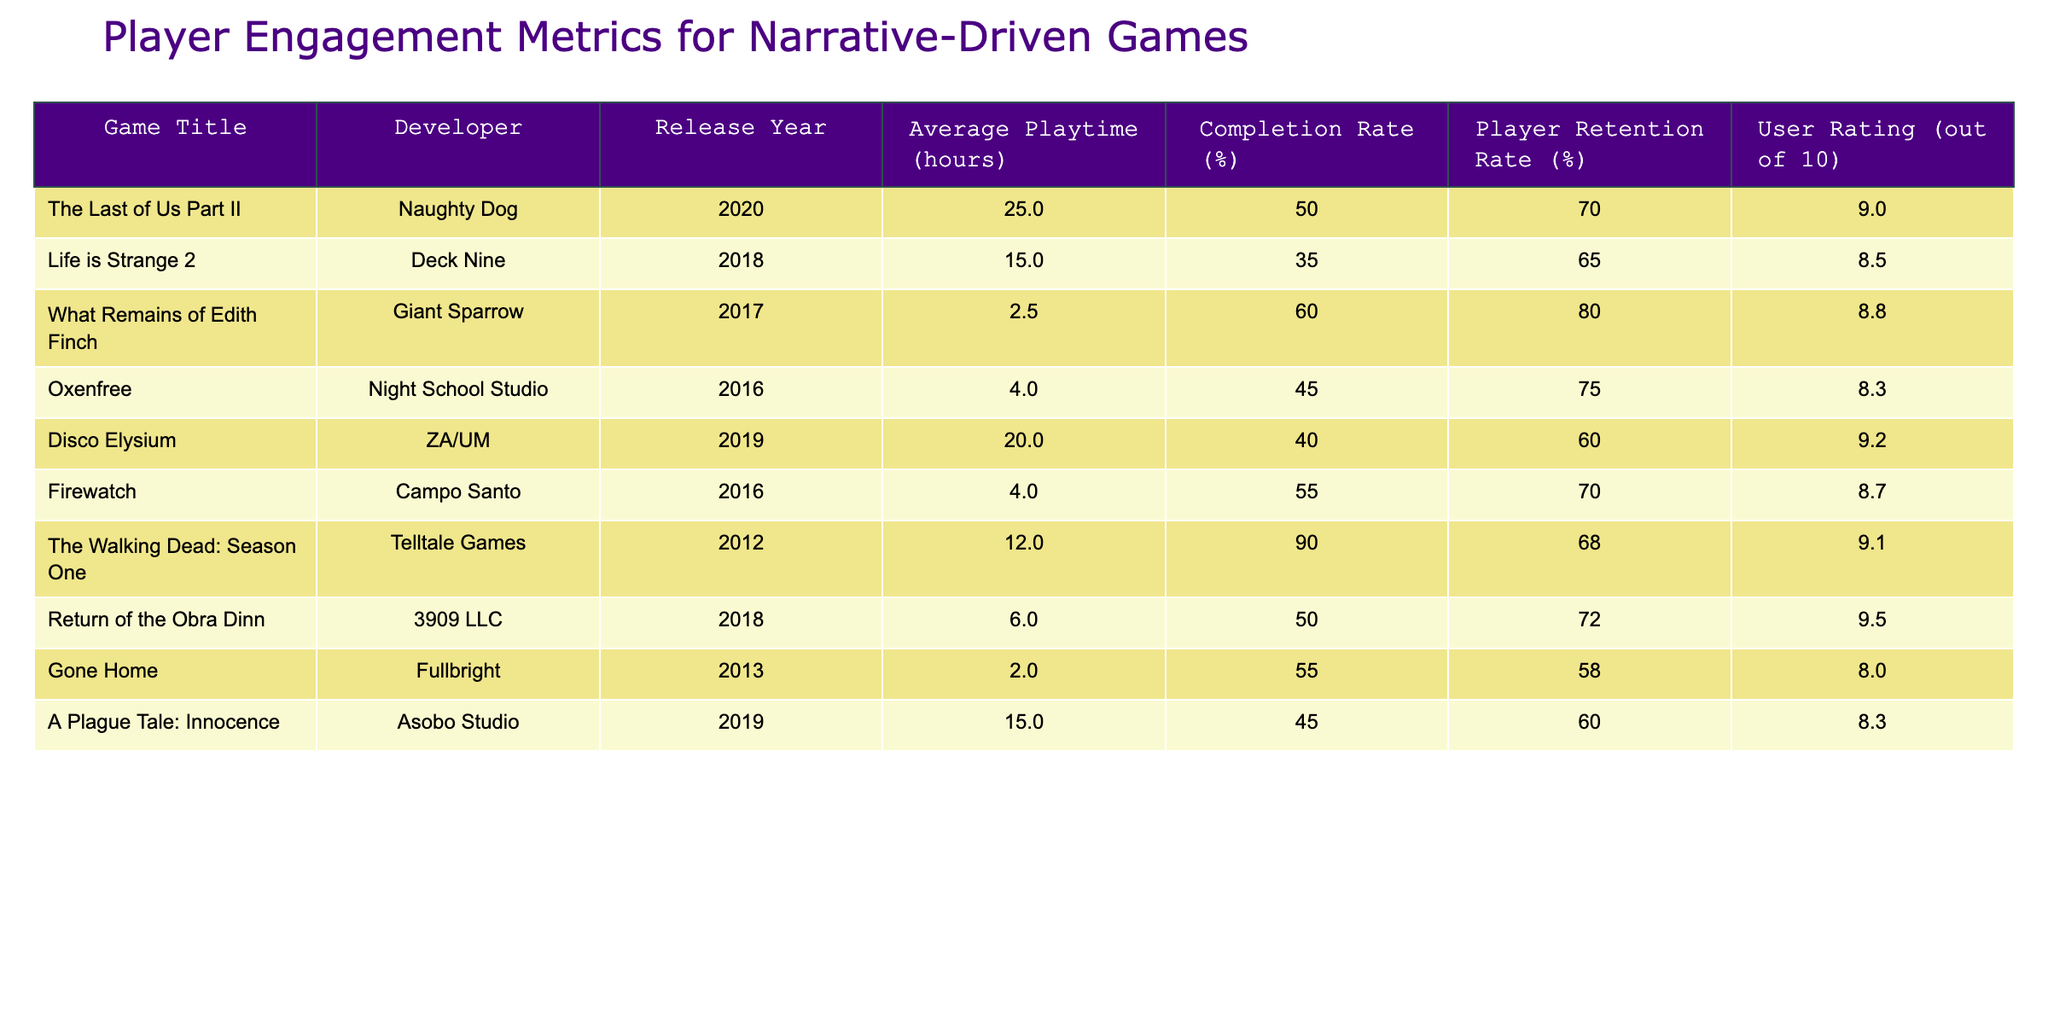What game has the highest player retention rate? By reviewing the "Player Retention Rate (%)" column in the table, we can see that "What Remains of Edith Finch" has a player retention rate of 80%, which is the highest among all the games listed.
Answer: What Remains of Edith Finch What is the average playtime of the games developed by Naughty Dog? The table shows that "The Last of Us Part II" is the only game by Naughty Dog, with an average playtime of 25 hours. Thus, the average playtime is simply 25 hours.
Answer: 25 hours What percentage of players completed "Life is Strange 2"? In the table, we find that "Life is Strange 2" has a completion rate of 35% listed under the "Completion Rate (%)" column.
Answer: 35% Is the user rating for "Return of the Obra Dinn" greater than 9? Looking at the "User Rating (out of 10)" column, "Return of the Obra Dinn" has a rating of 9.5, which is greater than 9, so the answer is yes.
Answer: Yes What is the difference in average playtime between "Oxenfree" and "Gone Home"? The average playtime for "Oxenfree" is 4 hours and for "Gone Home" it is 2 hours. The difference is calculated as 4 - 2 = 2 hours.
Answer: 2 hours Which game has the lowest user rating and what is it? By examining the "User Rating (out of 10)" column, we find that "Gone Home" has the lowest rating at 8.0 out of 10.
Answer: 8.0 What is the average completion rate of all the games listed? To find the average completion rate, we sum all completion rates: (50 + 35 + 60 + 45 + 40 + 55 + 90 + 50 + 55 + 45) =  455. There are 10 games, so the average is 455 / 10 = 45.5%.
Answer: 45.5% Are there any games with a user rating of 9 or higher that were released after 2015? By analyzing the table, we see that "The Last of Us Part II", "Disco Elysium", "Return of the Obra Dinn", and "The Walking Dead: Season One" all have ratings of 9 or higher and were released after 2015. Therefore, the answer is yes.
Answer: Yes What is the total average playtime of all the games from 2019? The games from 2019 are "Disco Elysium" and "A Plague Tale: Innocence", with average playtimes of 20 and 15 hours respectively. The total average playtime is 20 + 15 = 35 hours. Thus, dividing by 2 games gives us an average of 35 / 2 = 17.5 hours.
Answer: 17.5 hours 